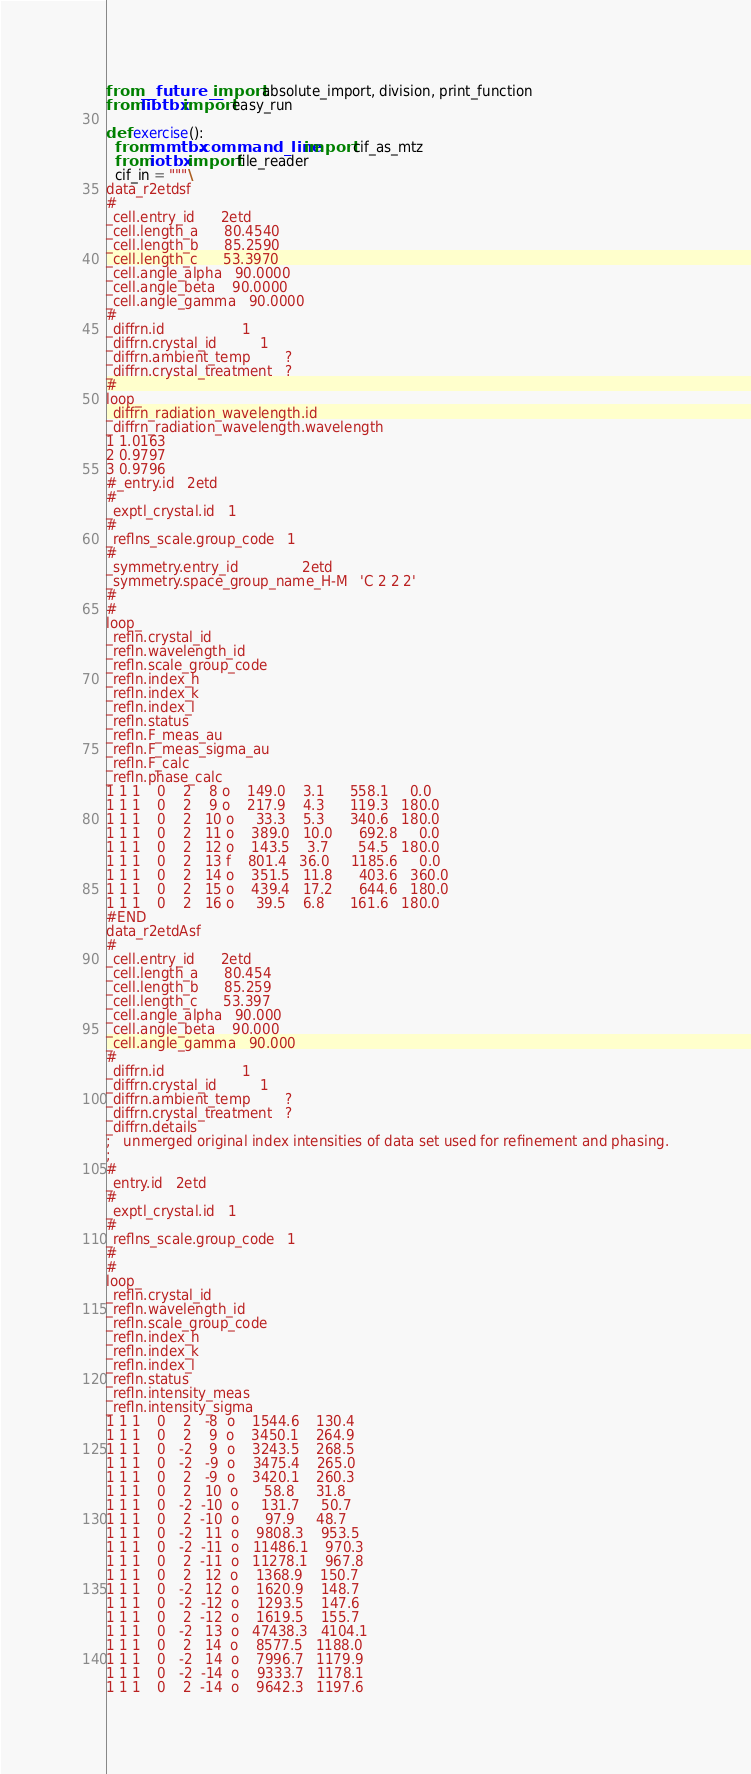Convert code to text. <code><loc_0><loc_0><loc_500><loc_500><_Python_>
from __future__ import absolute_import, division, print_function
from libtbx import easy_run

def exercise():
  from mmtbx.command_line import cif_as_mtz
  from iotbx import file_reader
  cif_in = """\
data_r2etdsf
#
_cell.entry_id      2etd
_cell.length_a      80.4540
_cell.length_b      85.2590
_cell.length_c      53.3970
_cell.angle_alpha   90.0000
_cell.angle_beta    90.0000
_cell.angle_gamma   90.0000
#
_diffrn.id                  1
_diffrn.crystal_id          1
_diffrn.ambient_temp        ?
_diffrn.crystal_treatment   ?
#
loop_
_diffrn_radiation_wavelength.id
_diffrn_radiation_wavelength.wavelength
1 1.0163
2 0.9797
3 0.9796
#_entry.id   2etd
#
_exptl_crystal.id   1
#
_reflns_scale.group_code   1
#
_symmetry.entry_id               2etd
_symmetry.space_group_name_H-M   'C 2 2 2'
#
#
loop_
_refln.crystal_id
_refln.wavelength_id
_refln.scale_group_code
_refln.index_h
_refln.index_k
_refln.index_l
_refln.status
_refln.F_meas_au
_refln.F_meas_sigma_au
_refln.F_calc
_refln.phase_calc
1 1 1    0    2    8 o    149.0    3.1      558.1     0.0
1 1 1    0    2    9 o    217.9    4.3      119.3   180.0
1 1 1    0    2   10 o     33.3    5.3      340.6   180.0
1 1 1    0    2   11 o    389.0   10.0      692.8     0.0
1 1 1    0    2   12 o    143.5    3.7       54.5   180.0
1 1 1    0    2   13 f    801.4   36.0     1185.6     0.0
1 1 1    0    2   14 o    351.5   11.8      403.6   360.0
1 1 1    0    2   15 o    439.4   17.2      644.6   180.0
1 1 1    0    2   16 o     39.5    6.8      161.6   180.0
#END
data_r2etdAsf
#
_cell.entry_id      2etd
_cell.length_a      80.454
_cell.length_b      85.259
_cell.length_c      53.397
_cell.angle_alpha   90.000
_cell.angle_beta    90.000
_cell.angle_gamma   90.000
#
_diffrn.id                  1
_diffrn.crystal_id          1
_diffrn.ambient_temp        ?
_diffrn.crystal_treatment   ?
_diffrn.details
;   unmerged original index intensities of data set used for refinement and phasing.
;
#
_entry.id   2etd
#
_exptl_crystal.id   1
#
_reflns_scale.group_code   1
#
#
loop_
_refln.crystal_id
_refln.wavelength_id
_refln.scale_group_code
_refln.index_h
_refln.index_k
_refln.index_l
_refln.status
_refln.intensity_meas
_refln.intensity_sigma
1 1 1    0    2   -8  o    1544.6    130.4
1 1 1    0    2    9  o    3450.1    264.9
1 1 1    0   -2    9  o    3243.5    268.5
1 1 1    0   -2   -9  o    3475.4    265.0
1 1 1    0    2   -9  o    3420.1    260.3
1 1 1    0    2   10  o      58.8     31.8
1 1 1    0   -2  -10  o     131.7     50.7
1 1 1    0    2  -10  o      97.9     48.7
1 1 1    0   -2   11  o    9808.3    953.5
1 1 1    0   -2  -11  o   11486.1    970.3
1 1 1    0    2  -11  o   11278.1    967.8
1 1 1    0    2   12  o    1368.9    150.7
1 1 1    0   -2   12  o    1620.9    148.7
1 1 1    0   -2  -12  o    1293.5    147.6
1 1 1    0    2  -12  o    1619.5    155.7
1 1 1    0   -2   13  o   47438.3   4104.1
1 1 1    0    2   14  o    8577.5   1188.0
1 1 1    0   -2   14  o    7996.7   1179.9
1 1 1    0   -2  -14  o    9333.7   1178.1
1 1 1    0    2  -14  o    9642.3   1197.6</code> 